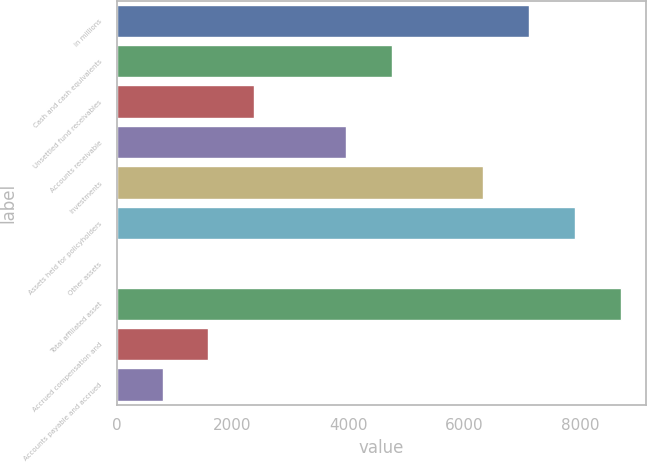Convert chart. <chart><loc_0><loc_0><loc_500><loc_500><bar_chart><fcel>in millions<fcel>Cash and cash equivalents<fcel>Unsettled fund receivables<fcel>Accounts receivable<fcel>Investments<fcel>Assets held for policyholders<fcel>Other assets<fcel>Total affiliated asset<fcel>Accrued compensation and<fcel>Accounts payable and accrued<nl><fcel>7114.84<fcel>4744.36<fcel>2373.88<fcel>3954.2<fcel>6324.68<fcel>7905<fcel>3.4<fcel>8695.16<fcel>1583.72<fcel>793.56<nl></chart> 